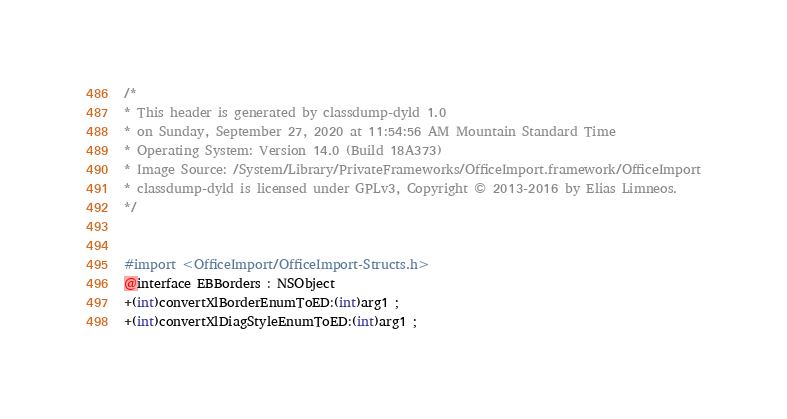<code> <loc_0><loc_0><loc_500><loc_500><_C_>/*
* This header is generated by classdump-dyld 1.0
* on Sunday, September 27, 2020 at 11:54:56 AM Mountain Standard Time
* Operating System: Version 14.0 (Build 18A373)
* Image Source: /System/Library/PrivateFrameworks/OfficeImport.framework/OfficeImport
* classdump-dyld is licensed under GPLv3, Copyright © 2013-2016 by Elias Limneos.
*/


#import <OfficeImport/OfficeImport-Structs.h>
@interface EBBorders : NSObject
+(int)convertXlBorderEnumToED:(int)arg1 ;
+(int)convertXlDiagStyleEnumToED:(int)arg1 ;</code> 